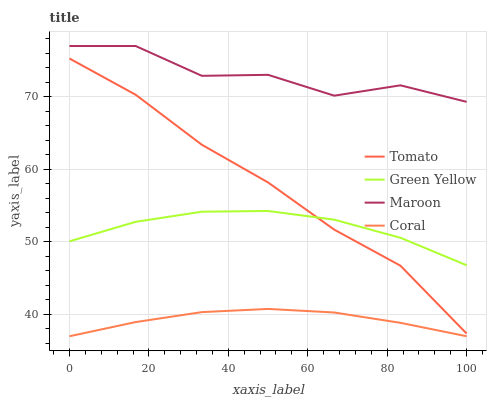Does Green Yellow have the minimum area under the curve?
Answer yes or no. No. Does Green Yellow have the maximum area under the curve?
Answer yes or no. No. Is Green Yellow the smoothest?
Answer yes or no. No. Is Green Yellow the roughest?
Answer yes or no. No. Does Green Yellow have the lowest value?
Answer yes or no. No. Does Green Yellow have the highest value?
Answer yes or no. No. Is Tomato less than Maroon?
Answer yes or no. Yes. Is Green Yellow greater than Coral?
Answer yes or no. Yes. Does Tomato intersect Maroon?
Answer yes or no. No. 